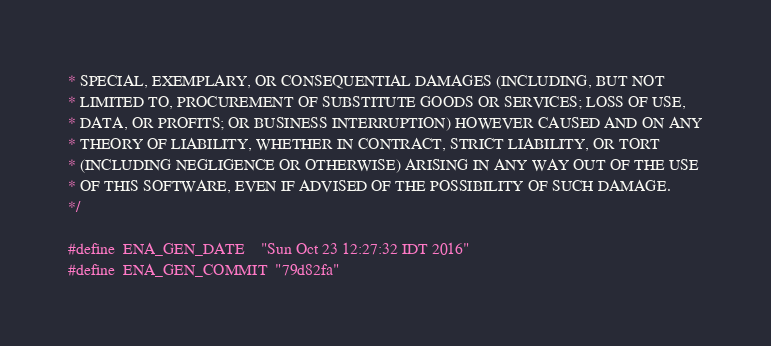Convert code to text. <code><loc_0><loc_0><loc_500><loc_500><_C_>* SPECIAL, EXEMPLARY, OR CONSEQUENTIAL DAMAGES (INCLUDING, BUT NOT
* LIMITED TO, PROCUREMENT OF SUBSTITUTE GOODS OR SERVICES; LOSS OF USE,
* DATA, OR PROFITS; OR BUSINESS INTERRUPTION) HOWEVER CAUSED AND ON ANY
* THEORY OF LIABILITY, WHETHER IN CONTRACT, STRICT LIABILITY, OR TORT
* (INCLUDING NEGLIGENCE OR OTHERWISE) ARISING IN ANY WAY OUT OF THE USE
* OF THIS SOFTWARE, EVEN IF ADVISED OF THE POSSIBILITY OF SUCH DAMAGE.
*/

#define	ENA_GEN_DATE	"Sun Oct 23 12:27:32 IDT 2016"
#define	ENA_GEN_COMMIT	"79d82fa"
</code> 